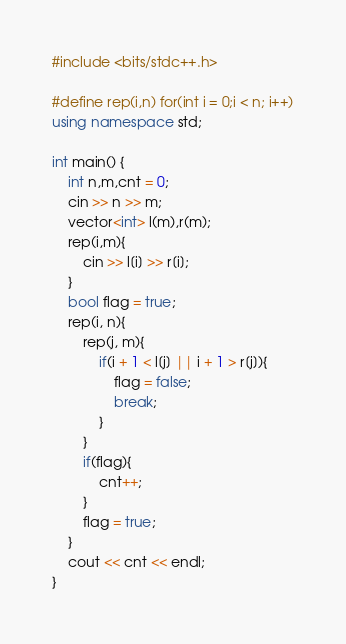<code> <loc_0><loc_0><loc_500><loc_500><_C++_>#include <bits/stdc++.h>

#define rep(i,n) for(int i = 0;i < n; i++)
using namespace std;

int main() {
    int n,m,cnt = 0;
    cin >> n >> m;
    vector<int> l(m),r(m);
    rep(i,m){
        cin >> l[i] >> r[i];
    }
    bool flag = true;
    rep(i, n){
        rep(j, m){
            if(i + 1 < l[j] || i + 1 > r[j]){
                flag = false;
                break;
            }
        }
        if(flag){
            cnt++;
        }
        flag = true;
    }
    cout << cnt << endl;
}
</code> 